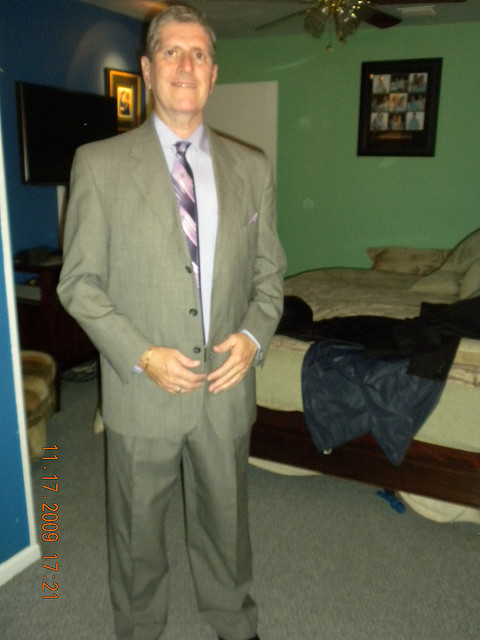Please transcribe the text information in this image. 21 17 2009 17 11 